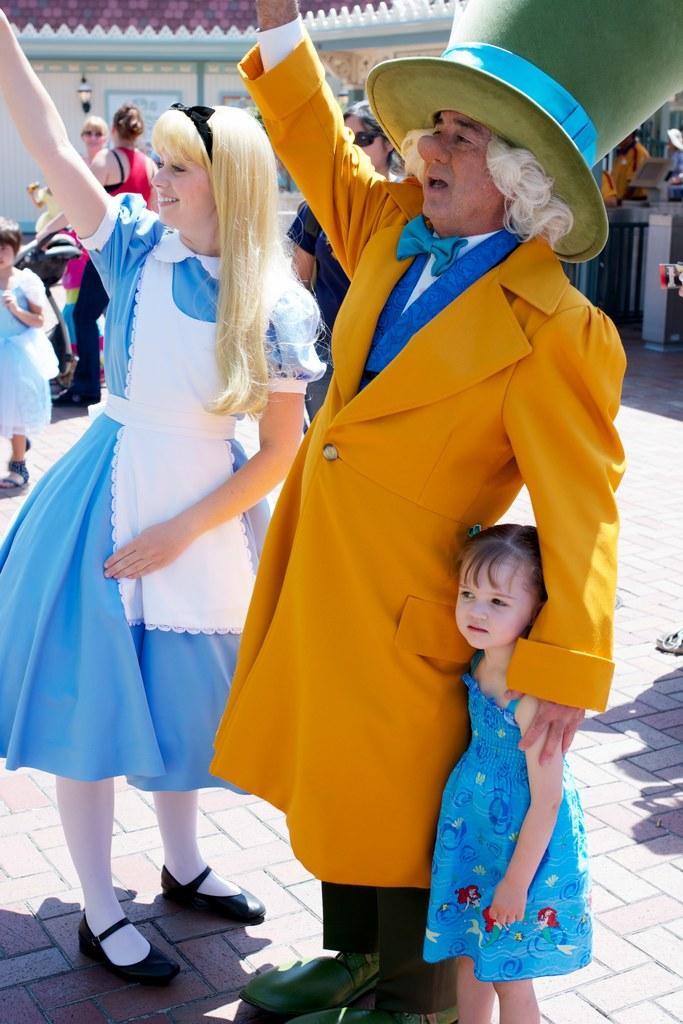Describe this image in one or two sentences. In this picture I can see group of people standing. I can see a building and there are some objects. 